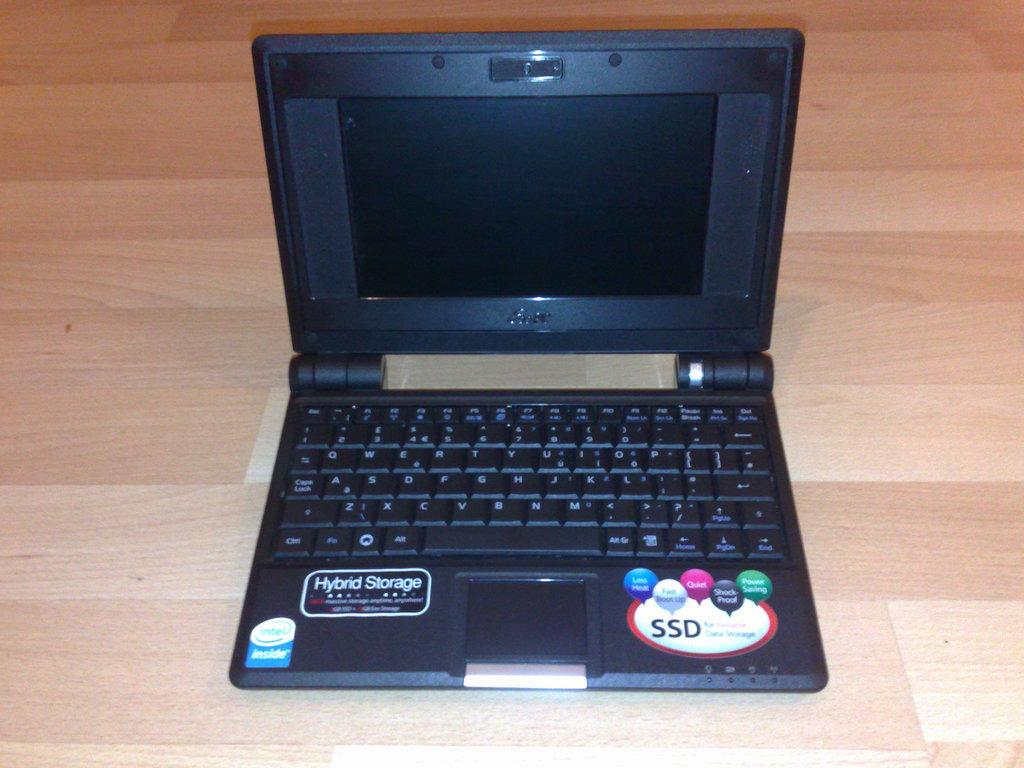Provide a one-sentence caption for the provided image. A small laptop has features which include Hybrid Storage and an SSD. 